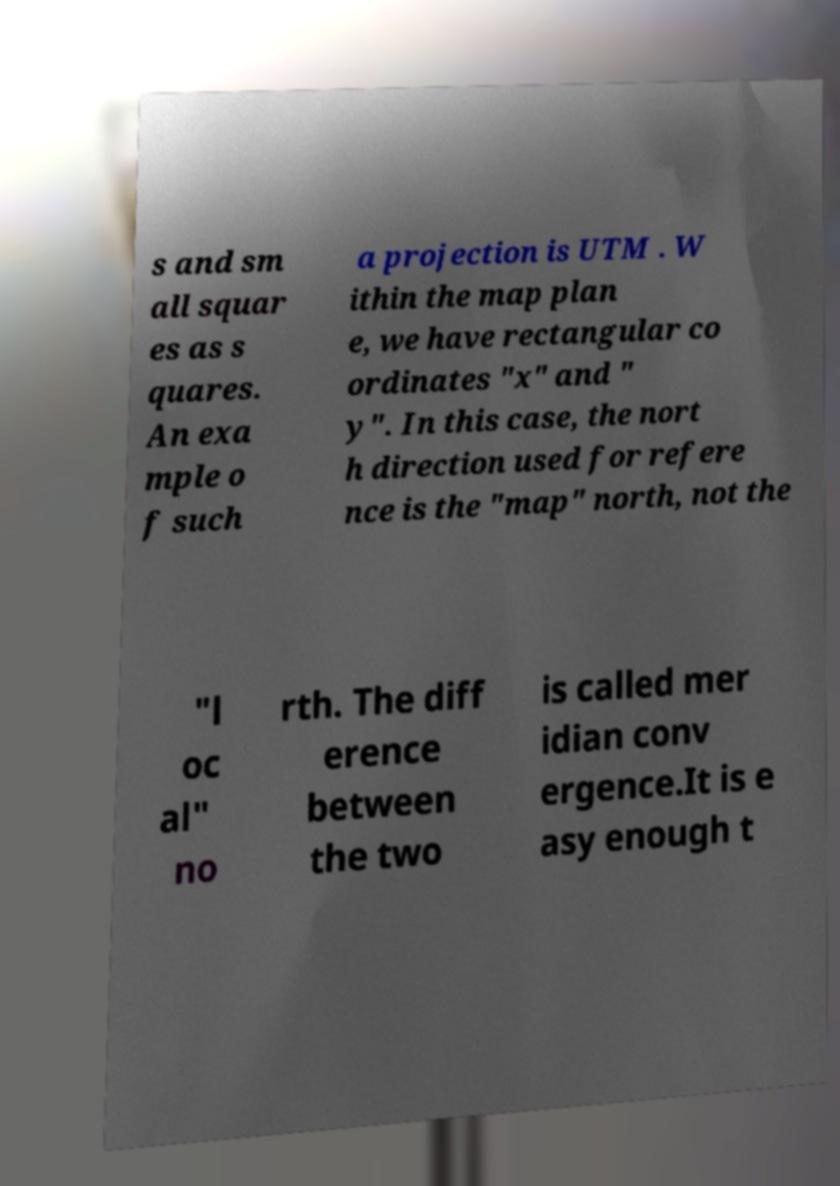Please identify and transcribe the text found in this image. s and sm all squar es as s quares. An exa mple o f such a projection is UTM . W ithin the map plan e, we have rectangular co ordinates "x" and " y". In this case, the nort h direction used for refere nce is the "map" north, not the "l oc al" no rth. The diff erence between the two is called mer idian conv ergence.It is e asy enough t 